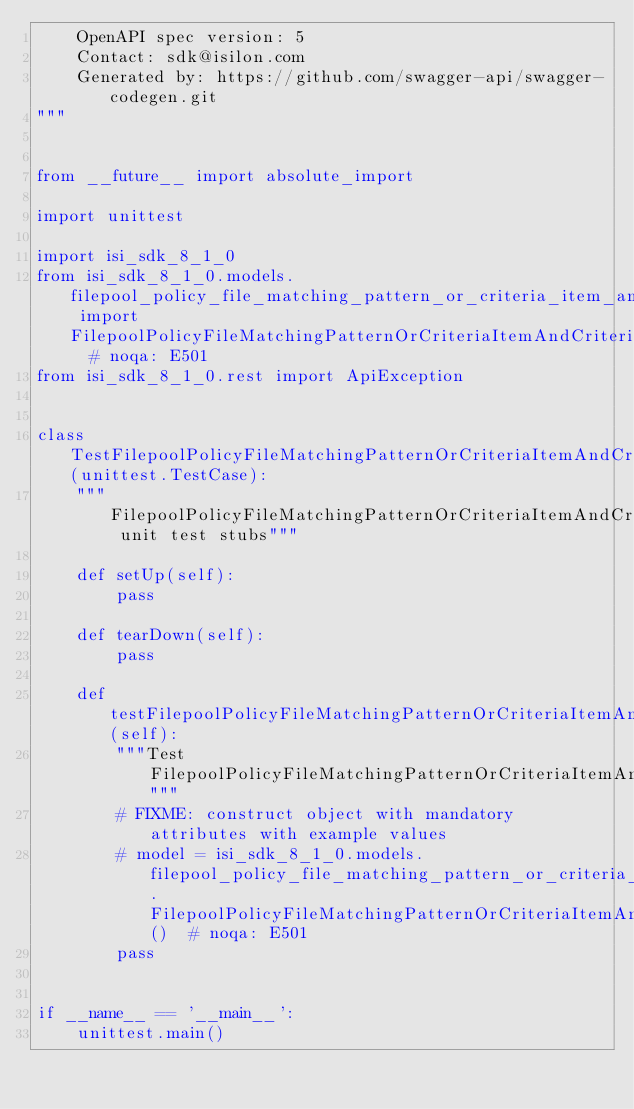<code> <loc_0><loc_0><loc_500><loc_500><_Python_>    OpenAPI spec version: 5
    Contact: sdk@isilon.com
    Generated by: https://github.com/swagger-api/swagger-codegen.git
"""


from __future__ import absolute_import

import unittest

import isi_sdk_8_1_0
from isi_sdk_8_1_0.models.filepool_policy_file_matching_pattern_or_criteria_item_and_criteria_item import FilepoolPolicyFileMatchingPatternOrCriteriaItemAndCriteriaItem  # noqa: E501
from isi_sdk_8_1_0.rest import ApiException


class TestFilepoolPolicyFileMatchingPatternOrCriteriaItemAndCriteriaItem(unittest.TestCase):
    """FilepoolPolicyFileMatchingPatternOrCriteriaItemAndCriteriaItem unit test stubs"""

    def setUp(self):
        pass

    def tearDown(self):
        pass

    def testFilepoolPolicyFileMatchingPatternOrCriteriaItemAndCriteriaItem(self):
        """Test FilepoolPolicyFileMatchingPatternOrCriteriaItemAndCriteriaItem"""
        # FIXME: construct object with mandatory attributes with example values
        # model = isi_sdk_8_1_0.models.filepool_policy_file_matching_pattern_or_criteria_item_and_criteria_item.FilepoolPolicyFileMatchingPatternOrCriteriaItemAndCriteriaItem()  # noqa: E501
        pass


if __name__ == '__main__':
    unittest.main()
</code> 